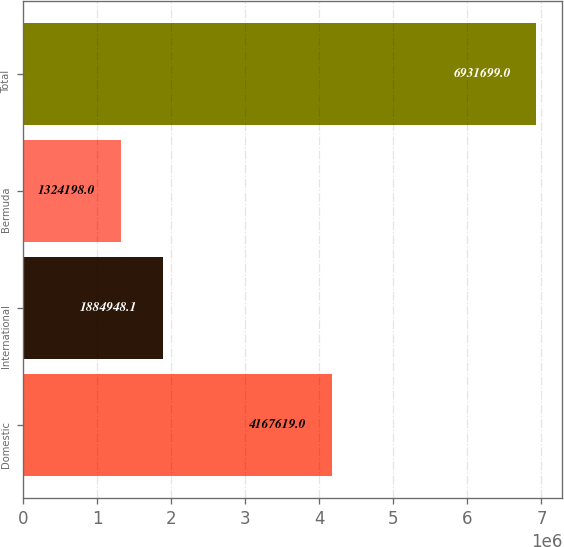<chart> <loc_0><loc_0><loc_500><loc_500><bar_chart><fcel>Domestic<fcel>International<fcel>Bermuda<fcel>Total<nl><fcel>4.16762e+06<fcel>1.88495e+06<fcel>1.3242e+06<fcel>6.9317e+06<nl></chart> 